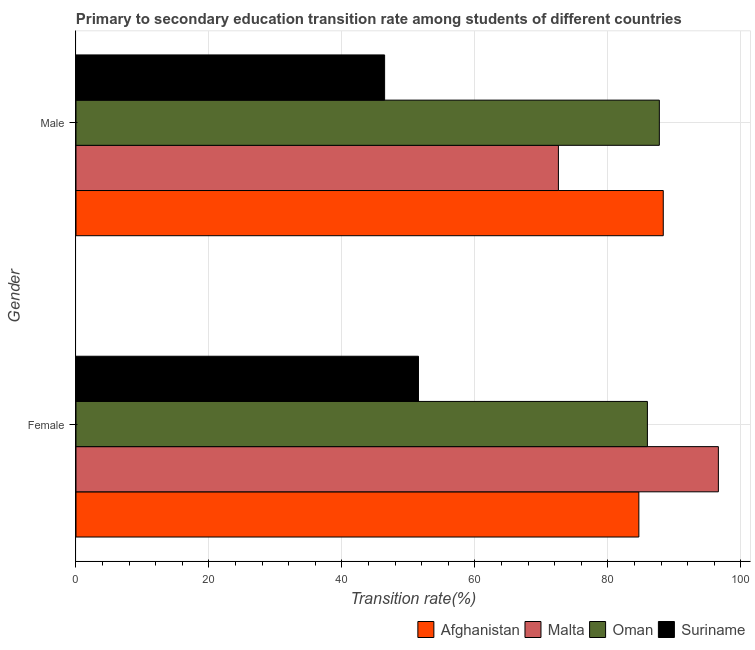How many groups of bars are there?
Provide a short and direct response. 2. Are the number of bars on each tick of the Y-axis equal?
Make the answer very short. Yes. How many bars are there on the 2nd tick from the top?
Provide a short and direct response. 4. How many bars are there on the 1st tick from the bottom?
Provide a short and direct response. 4. What is the label of the 2nd group of bars from the top?
Give a very brief answer. Female. What is the transition rate among female students in Oman?
Ensure brevity in your answer.  85.95. Across all countries, what is the maximum transition rate among female students?
Give a very brief answer. 96.63. Across all countries, what is the minimum transition rate among female students?
Provide a succinct answer. 51.52. In which country was the transition rate among female students maximum?
Your answer should be compact. Malta. In which country was the transition rate among male students minimum?
Your answer should be compact. Suriname. What is the total transition rate among male students in the graph?
Keep it short and to the point. 295.08. What is the difference between the transition rate among female students in Malta and that in Suriname?
Offer a very short reply. 45.11. What is the difference between the transition rate among female students in Suriname and the transition rate among male students in Malta?
Make the answer very short. -21.05. What is the average transition rate among female students per country?
Keep it short and to the point. 79.69. What is the difference between the transition rate among male students and transition rate among female students in Suriname?
Make the answer very short. -5.09. What is the ratio of the transition rate among female students in Oman to that in Afghanistan?
Give a very brief answer. 1.02. Is the transition rate among female students in Suriname less than that in Malta?
Give a very brief answer. Yes. What does the 3rd bar from the top in Male represents?
Offer a very short reply. Malta. What does the 2nd bar from the bottom in Male represents?
Keep it short and to the point. Malta. How many bars are there?
Keep it short and to the point. 8. How many countries are there in the graph?
Your answer should be compact. 4. Does the graph contain any zero values?
Offer a terse response. No. How many legend labels are there?
Give a very brief answer. 4. How are the legend labels stacked?
Offer a very short reply. Horizontal. What is the title of the graph?
Your answer should be very brief. Primary to secondary education transition rate among students of different countries. Does "Senegal" appear as one of the legend labels in the graph?
Ensure brevity in your answer.  No. What is the label or title of the X-axis?
Make the answer very short. Transition rate(%). What is the Transition rate(%) in Afghanistan in Female?
Your response must be concise. 84.67. What is the Transition rate(%) of Malta in Female?
Provide a succinct answer. 96.63. What is the Transition rate(%) in Oman in Female?
Your response must be concise. 85.95. What is the Transition rate(%) of Suriname in Female?
Your answer should be compact. 51.52. What is the Transition rate(%) in Afghanistan in Male?
Keep it short and to the point. 88.34. What is the Transition rate(%) in Malta in Male?
Offer a terse response. 72.57. What is the Transition rate(%) of Oman in Male?
Offer a very short reply. 87.75. What is the Transition rate(%) of Suriname in Male?
Provide a succinct answer. 46.42. Across all Gender, what is the maximum Transition rate(%) of Afghanistan?
Provide a short and direct response. 88.34. Across all Gender, what is the maximum Transition rate(%) in Malta?
Your response must be concise. 96.63. Across all Gender, what is the maximum Transition rate(%) in Oman?
Keep it short and to the point. 87.75. Across all Gender, what is the maximum Transition rate(%) in Suriname?
Provide a succinct answer. 51.52. Across all Gender, what is the minimum Transition rate(%) of Afghanistan?
Your response must be concise. 84.67. Across all Gender, what is the minimum Transition rate(%) of Malta?
Your response must be concise. 72.57. Across all Gender, what is the minimum Transition rate(%) in Oman?
Provide a succinct answer. 85.95. Across all Gender, what is the minimum Transition rate(%) of Suriname?
Offer a terse response. 46.42. What is the total Transition rate(%) of Afghanistan in the graph?
Ensure brevity in your answer.  173.01. What is the total Transition rate(%) in Malta in the graph?
Provide a short and direct response. 169.19. What is the total Transition rate(%) in Oman in the graph?
Keep it short and to the point. 173.7. What is the total Transition rate(%) in Suriname in the graph?
Your answer should be very brief. 97.94. What is the difference between the Transition rate(%) in Afghanistan in Female and that in Male?
Your response must be concise. -3.67. What is the difference between the Transition rate(%) of Malta in Female and that in Male?
Offer a very short reply. 24.06. What is the difference between the Transition rate(%) of Oman in Female and that in Male?
Give a very brief answer. -1.8. What is the difference between the Transition rate(%) in Suriname in Female and that in Male?
Your response must be concise. 5.09. What is the difference between the Transition rate(%) of Afghanistan in Female and the Transition rate(%) of Malta in Male?
Ensure brevity in your answer.  12.1. What is the difference between the Transition rate(%) of Afghanistan in Female and the Transition rate(%) of Oman in Male?
Your answer should be very brief. -3.08. What is the difference between the Transition rate(%) in Afghanistan in Female and the Transition rate(%) in Suriname in Male?
Offer a terse response. 38.24. What is the difference between the Transition rate(%) of Malta in Female and the Transition rate(%) of Oman in Male?
Your answer should be compact. 8.88. What is the difference between the Transition rate(%) in Malta in Female and the Transition rate(%) in Suriname in Male?
Provide a short and direct response. 50.21. What is the difference between the Transition rate(%) of Oman in Female and the Transition rate(%) of Suriname in Male?
Your answer should be compact. 39.53. What is the average Transition rate(%) of Afghanistan per Gender?
Your response must be concise. 86.5. What is the average Transition rate(%) of Malta per Gender?
Provide a succinct answer. 84.6. What is the average Transition rate(%) of Oman per Gender?
Your answer should be compact. 86.85. What is the average Transition rate(%) of Suriname per Gender?
Offer a terse response. 48.97. What is the difference between the Transition rate(%) in Afghanistan and Transition rate(%) in Malta in Female?
Provide a short and direct response. -11.96. What is the difference between the Transition rate(%) in Afghanistan and Transition rate(%) in Oman in Female?
Your response must be concise. -1.28. What is the difference between the Transition rate(%) of Afghanistan and Transition rate(%) of Suriname in Female?
Your response must be concise. 33.15. What is the difference between the Transition rate(%) in Malta and Transition rate(%) in Oman in Female?
Provide a short and direct response. 10.68. What is the difference between the Transition rate(%) of Malta and Transition rate(%) of Suriname in Female?
Offer a terse response. 45.11. What is the difference between the Transition rate(%) in Oman and Transition rate(%) in Suriname in Female?
Make the answer very short. 34.44. What is the difference between the Transition rate(%) of Afghanistan and Transition rate(%) of Malta in Male?
Provide a short and direct response. 15.77. What is the difference between the Transition rate(%) of Afghanistan and Transition rate(%) of Oman in Male?
Your answer should be very brief. 0.59. What is the difference between the Transition rate(%) of Afghanistan and Transition rate(%) of Suriname in Male?
Keep it short and to the point. 41.92. What is the difference between the Transition rate(%) in Malta and Transition rate(%) in Oman in Male?
Offer a very short reply. -15.18. What is the difference between the Transition rate(%) of Malta and Transition rate(%) of Suriname in Male?
Keep it short and to the point. 26.14. What is the difference between the Transition rate(%) in Oman and Transition rate(%) in Suriname in Male?
Your response must be concise. 41.33. What is the ratio of the Transition rate(%) of Afghanistan in Female to that in Male?
Keep it short and to the point. 0.96. What is the ratio of the Transition rate(%) in Malta in Female to that in Male?
Offer a very short reply. 1.33. What is the ratio of the Transition rate(%) of Oman in Female to that in Male?
Keep it short and to the point. 0.98. What is the ratio of the Transition rate(%) of Suriname in Female to that in Male?
Give a very brief answer. 1.11. What is the difference between the highest and the second highest Transition rate(%) of Afghanistan?
Your answer should be very brief. 3.67. What is the difference between the highest and the second highest Transition rate(%) of Malta?
Your answer should be compact. 24.06. What is the difference between the highest and the second highest Transition rate(%) in Oman?
Ensure brevity in your answer.  1.8. What is the difference between the highest and the second highest Transition rate(%) of Suriname?
Keep it short and to the point. 5.09. What is the difference between the highest and the lowest Transition rate(%) in Afghanistan?
Keep it short and to the point. 3.67. What is the difference between the highest and the lowest Transition rate(%) in Malta?
Your answer should be compact. 24.06. What is the difference between the highest and the lowest Transition rate(%) of Oman?
Ensure brevity in your answer.  1.8. What is the difference between the highest and the lowest Transition rate(%) in Suriname?
Your response must be concise. 5.09. 